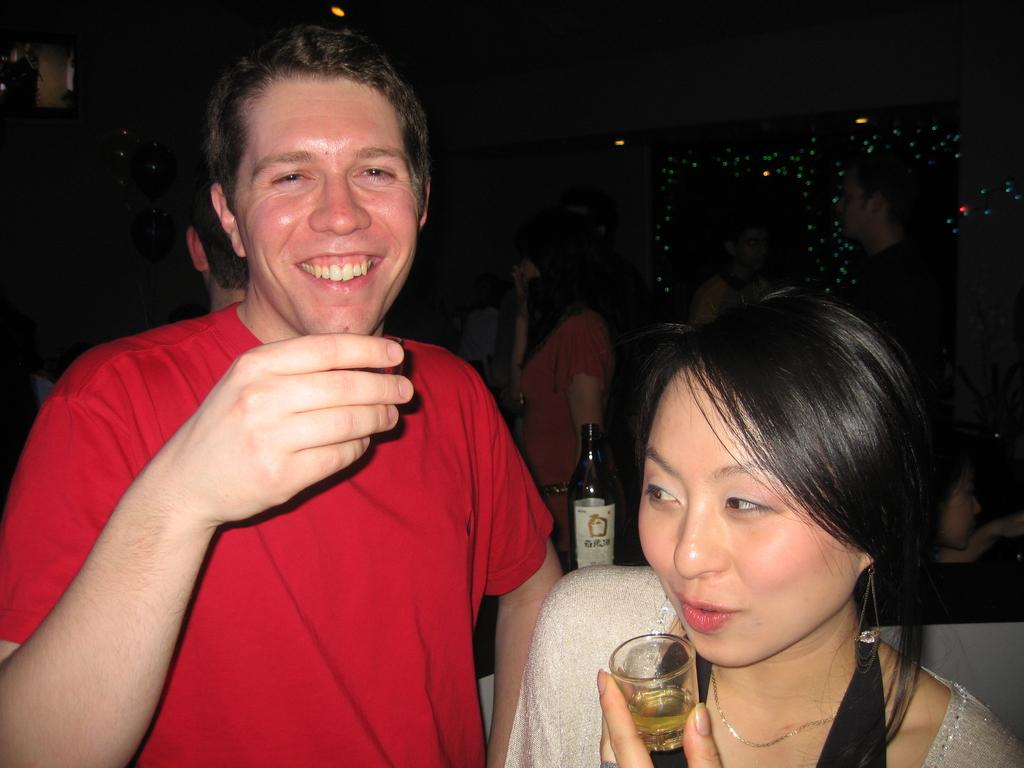Who is present in the image? There is a man and a woman in the image. What are the man and woman holding in the image? The man and woman are holding glasses in the image. What else can be seen in the image? There is a bottle in the image. What is visible in the background of the image? There is a light and people in the background of the image. How many icicles are hanging from the structure in the image? There is no structure or icicles present in the image. 